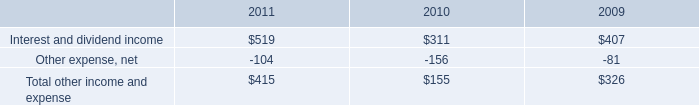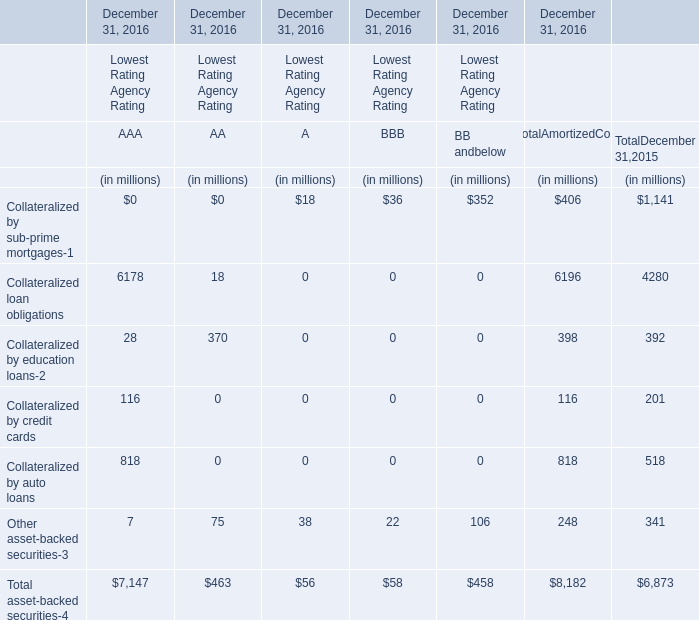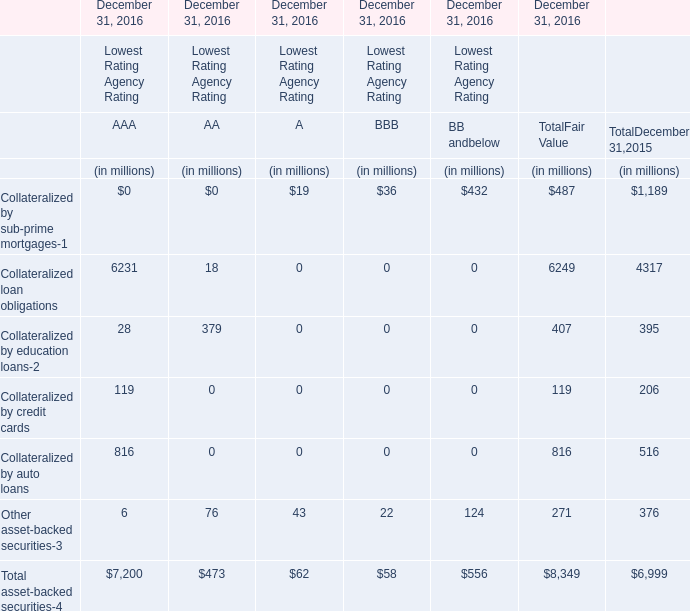What was the total amount ofCollateralized loan obligations Collateralized by education loans-2Collateralized by credit cards Collateralized by auto loans in AAA? (in million) 
Computations: (((6231 + 28) + 119) + 816)
Answer: 7194.0. 